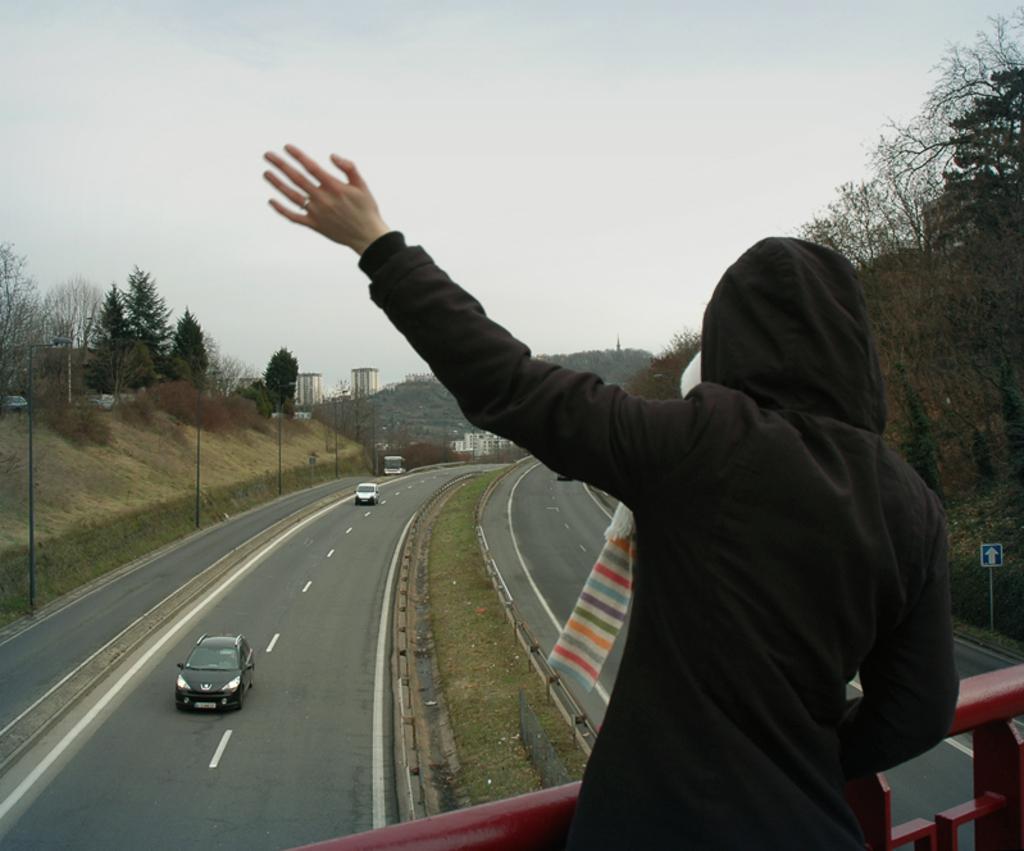Could you give a brief overview of what you see in this image? On the right side of the image we can see a person, in front of the person we can find few metal rods and vehicles on the road, in the background we can find few poles, trees and buildings, and also we can see a sign board on the right side of the image. 